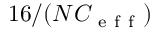<formula> <loc_0><loc_0><loc_500><loc_500>1 6 / ( N C _ { e f f } )</formula> 